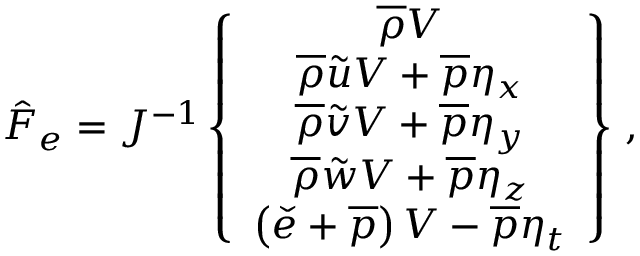<formula> <loc_0><loc_0><loc_500><loc_500>\hat { F } _ { e } = J ^ { - 1 } \left \{ \begin{array} { c } { \overline { \rho } V } \\ { \overline { \rho } \tilde { u } V + \overline { p } \eta _ { x } } \\ { \overline { \rho } \tilde { v } V + \overline { p } \eta _ { y } } \\ { \overline { \rho } \tilde { w } V + \overline { p } \eta _ { z } } \\ { \left ( \check { e } + \overline { p } \right ) V - \overline { p } \eta _ { t } } \end{array} \right \} \, ,</formula> 